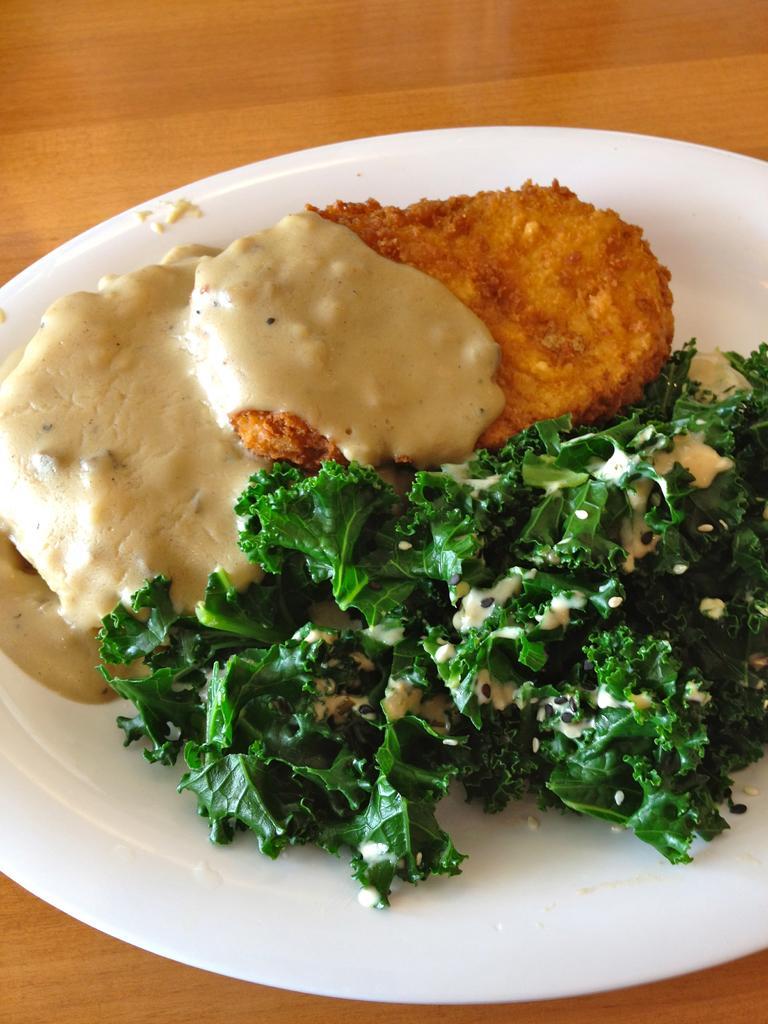Can you describe this image briefly? In this image, we can see food on the plate, which is placed on the table. 